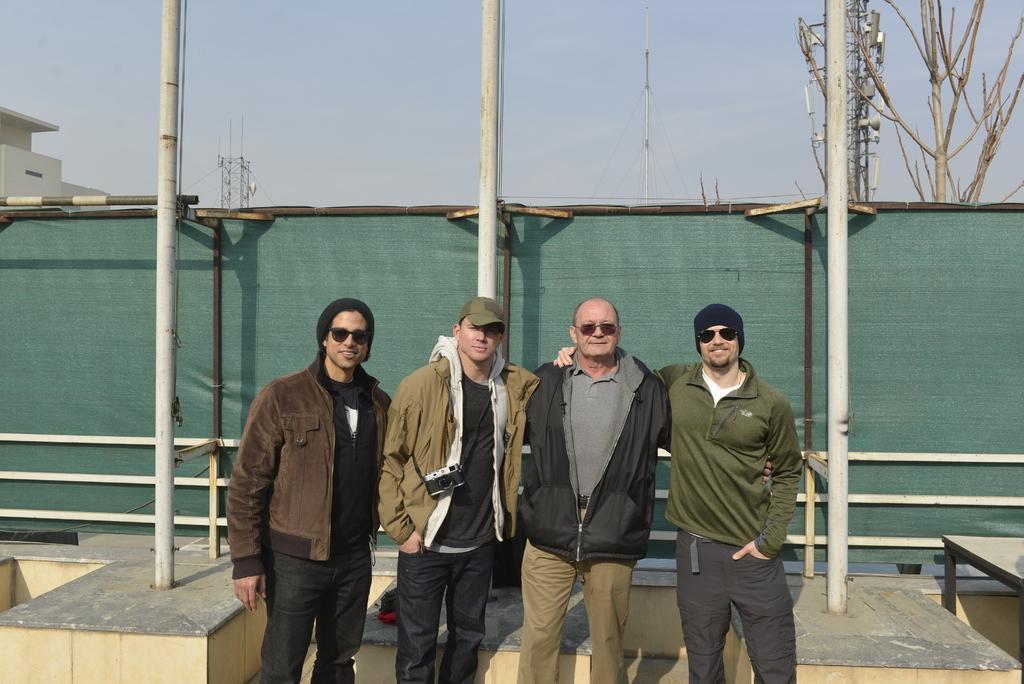Can you describe this image briefly? In this picture we can see there are four people standing on the path and behind the people there are poles, electric towers, tree, a house and a sky. 